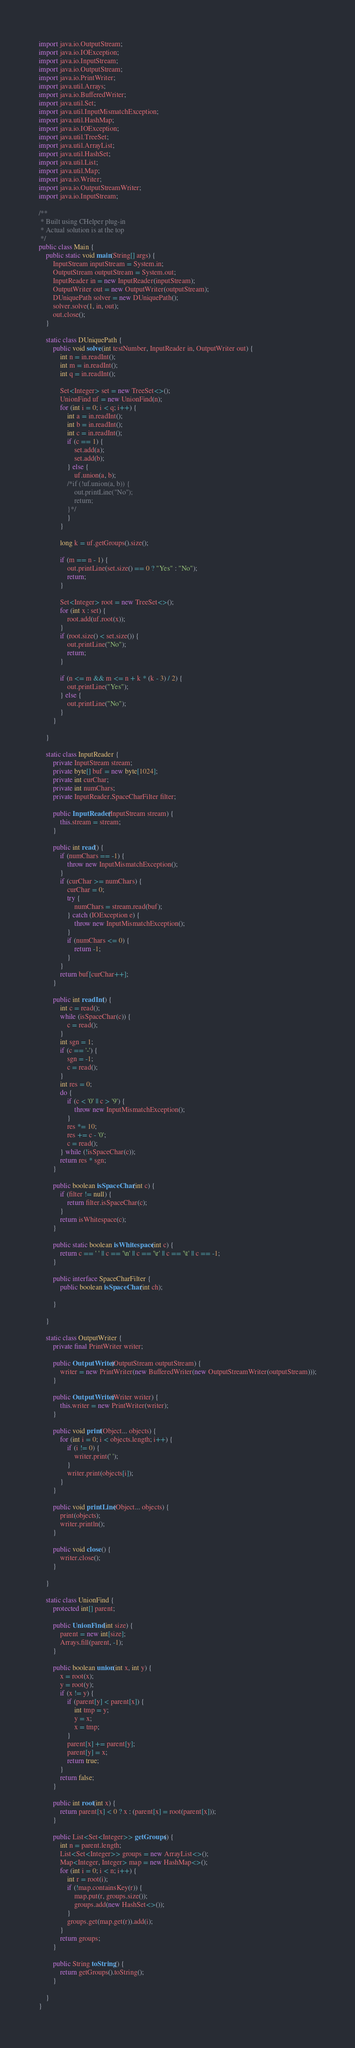Convert code to text. <code><loc_0><loc_0><loc_500><loc_500><_Java_>import java.io.OutputStream;
import java.io.IOException;
import java.io.InputStream;
import java.io.OutputStream;
import java.io.PrintWriter;
import java.util.Arrays;
import java.io.BufferedWriter;
import java.util.Set;
import java.util.InputMismatchException;
import java.util.HashMap;
import java.io.IOException;
import java.util.TreeSet;
import java.util.ArrayList;
import java.util.HashSet;
import java.util.List;
import java.util.Map;
import java.io.Writer;
import java.io.OutputStreamWriter;
import java.io.InputStream;

/**
 * Built using CHelper plug-in
 * Actual solution is at the top
 */
public class Main {
    public static void main(String[] args) {
        InputStream inputStream = System.in;
        OutputStream outputStream = System.out;
        InputReader in = new InputReader(inputStream);
        OutputWriter out = new OutputWriter(outputStream);
        DUniquePath solver = new DUniquePath();
        solver.solve(1, in, out);
        out.close();
    }

    static class DUniquePath {
        public void solve(int testNumber, InputReader in, OutputWriter out) {
            int n = in.readInt();
            int m = in.readInt();
            int q = in.readInt();

            Set<Integer> set = new TreeSet<>();
            UnionFind uf = new UnionFind(n);
            for (int i = 0; i < q; i++) {
                int a = in.readInt();
                int b = in.readInt();
                int c = in.readInt();
                if (c == 1) {
                    set.add(a);
                    set.add(b);
                } else {
                    uf.union(a, b);
                /*if (!uf.union(a, b)) {
                    out.printLine("No");
                    return;
                }*/
                }
            }

            long k = uf.getGroups().size();

            if (m == n - 1) {
                out.printLine(set.size() == 0 ? "Yes" : "No");
                return;
            }

            Set<Integer> root = new TreeSet<>();
            for (int x : set) {
                root.add(uf.root(x));
            }
            if (root.size() < set.size()) {
                out.printLine("No");
                return;
            }

            if (n <= m && m <= n + k * (k - 3) / 2) {
                out.printLine("Yes");
            } else {
                out.printLine("No");
            }
        }

    }

    static class InputReader {
        private InputStream stream;
        private byte[] buf = new byte[1024];
        private int curChar;
        private int numChars;
        private InputReader.SpaceCharFilter filter;

        public InputReader(InputStream stream) {
            this.stream = stream;
        }

        public int read() {
            if (numChars == -1) {
                throw new InputMismatchException();
            }
            if (curChar >= numChars) {
                curChar = 0;
                try {
                    numChars = stream.read(buf);
                } catch (IOException e) {
                    throw new InputMismatchException();
                }
                if (numChars <= 0) {
                    return -1;
                }
            }
            return buf[curChar++];
        }

        public int readInt() {
            int c = read();
            while (isSpaceChar(c)) {
                c = read();
            }
            int sgn = 1;
            if (c == '-') {
                sgn = -1;
                c = read();
            }
            int res = 0;
            do {
                if (c < '0' || c > '9') {
                    throw new InputMismatchException();
                }
                res *= 10;
                res += c - '0';
                c = read();
            } while (!isSpaceChar(c));
            return res * sgn;
        }

        public boolean isSpaceChar(int c) {
            if (filter != null) {
                return filter.isSpaceChar(c);
            }
            return isWhitespace(c);
        }

        public static boolean isWhitespace(int c) {
            return c == ' ' || c == '\n' || c == '\r' || c == '\t' || c == -1;
        }

        public interface SpaceCharFilter {
            public boolean isSpaceChar(int ch);

        }

    }

    static class OutputWriter {
        private final PrintWriter writer;

        public OutputWriter(OutputStream outputStream) {
            writer = new PrintWriter(new BufferedWriter(new OutputStreamWriter(outputStream)));
        }

        public OutputWriter(Writer writer) {
            this.writer = new PrintWriter(writer);
        }

        public void print(Object... objects) {
            for (int i = 0; i < objects.length; i++) {
                if (i != 0) {
                    writer.print(' ');
                }
                writer.print(objects[i]);
            }
        }

        public void printLine(Object... objects) {
            print(objects);
            writer.println();
        }

        public void close() {
            writer.close();
        }

    }

    static class UnionFind {
        protected int[] parent;

        public UnionFind(int size) {
            parent = new int[size];
            Arrays.fill(parent, -1);
        }

        public boolean union(int x, int y) {
            x = root(x);
            y = root(y);
            if (x != y) {
                if (parent[y] < parent[x]) {
                    int tmp = y;
                    y = x;
                    x = tmp;
                }
                parent[x] += parent[y];
                parent[y] = x;
                return true;
            }
            return false;
        }

        public int root(int x) {
            return parent[x] < 0 ? x : (parent[x] = root(parent[x]));
        }

        public List<Set<Integer>> getGroups() {
            int n = parent.length;
            List<Set<Integer>> groups = new ArrayList<>();
            Map<Integer, Integer> map = new HashMap<>();
            for (int i = 0; i < n; i++) {
                int r = root(i);
                if (!map.containsKey(r)) {
                    map.put(r, groups.size());
                    groups.add(new HashSet<>());
                }
                groups.get(map.get(r)).add(i);
            }
            return groups;
        }

        public String toString() {
            return getGroups().toString();
        }

    }
}

</code> 